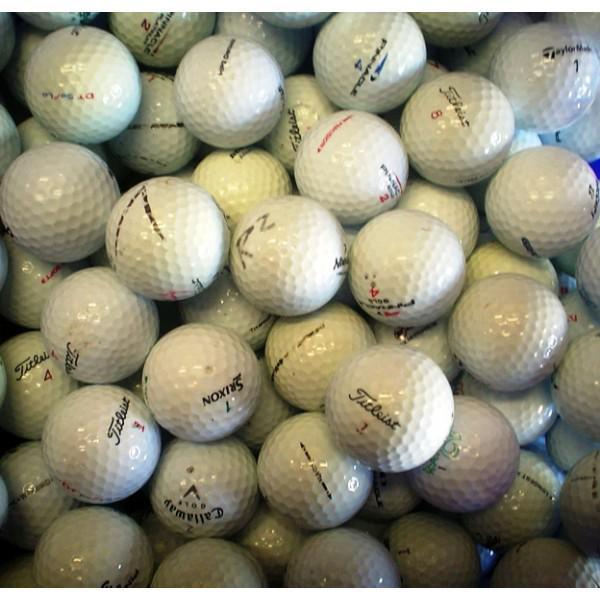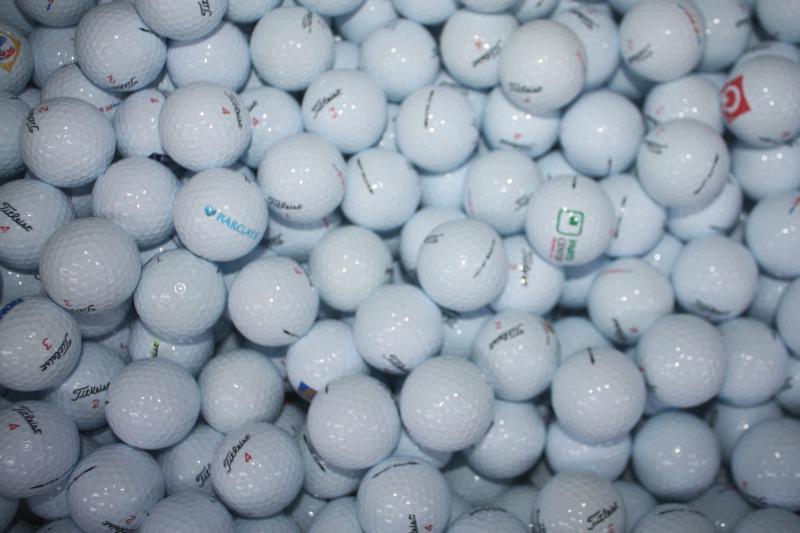The first image is the image on the left, the second image is the image on the right. Given the left and right images, does the statement "Some of the balls have an orange print" hold true? Answer yes or no. No. The first image is the image on the left, the second image is the image on the right. Considering the images on both sides, is "The balls in the image on the left are not in shadow" valid? Answer yes or no. Yes. 